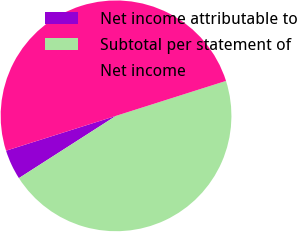<chart> <loc_0><loc_0><loc_500><loc_500><pie_chart><fcel>Net income attributable to<fcel>Subtotal per statement of<fcel>Net income<nl><fcel>4.19%<fcel>45.82%<fcel>49.99%<nl></chart> 